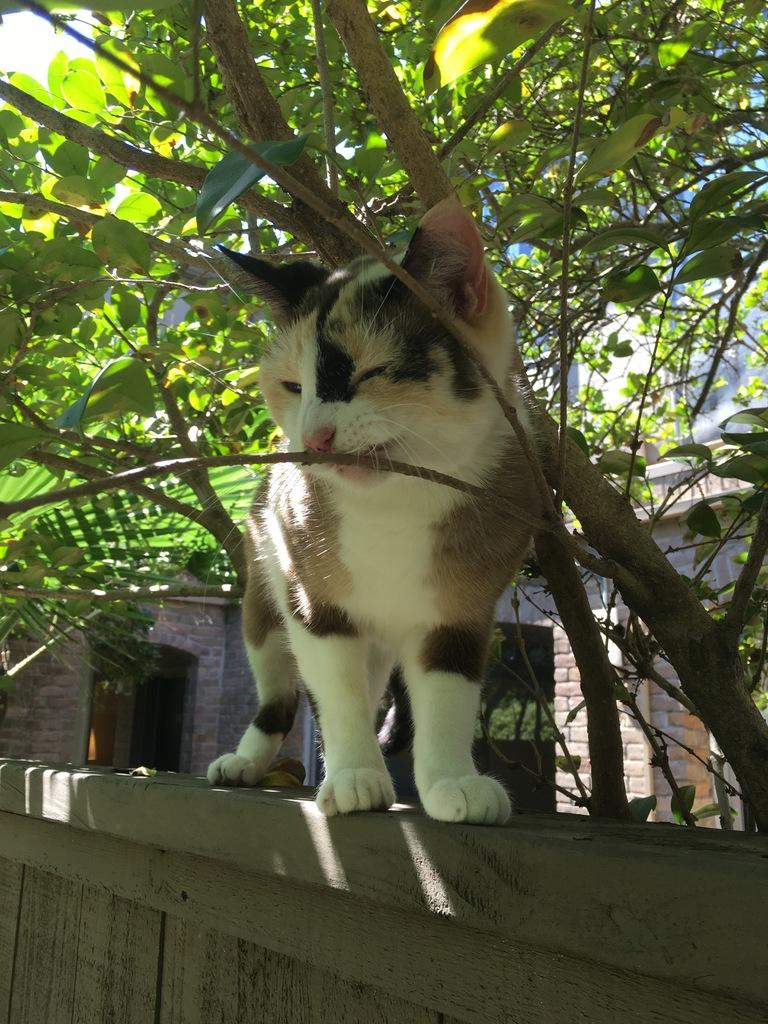What type of animal is in the image? There is a cat in the image. Where is the cat located in the image? The cat is on the wall. What can be seen in the background of the image? There are trees and buildings in the background of the image. What type of throne does the cat sit on in the image? There is no throne present in the image; the cat is on the wall. How does the cat rest in the image? The cat is on the wall, so it is not resting in the traditional sense. 